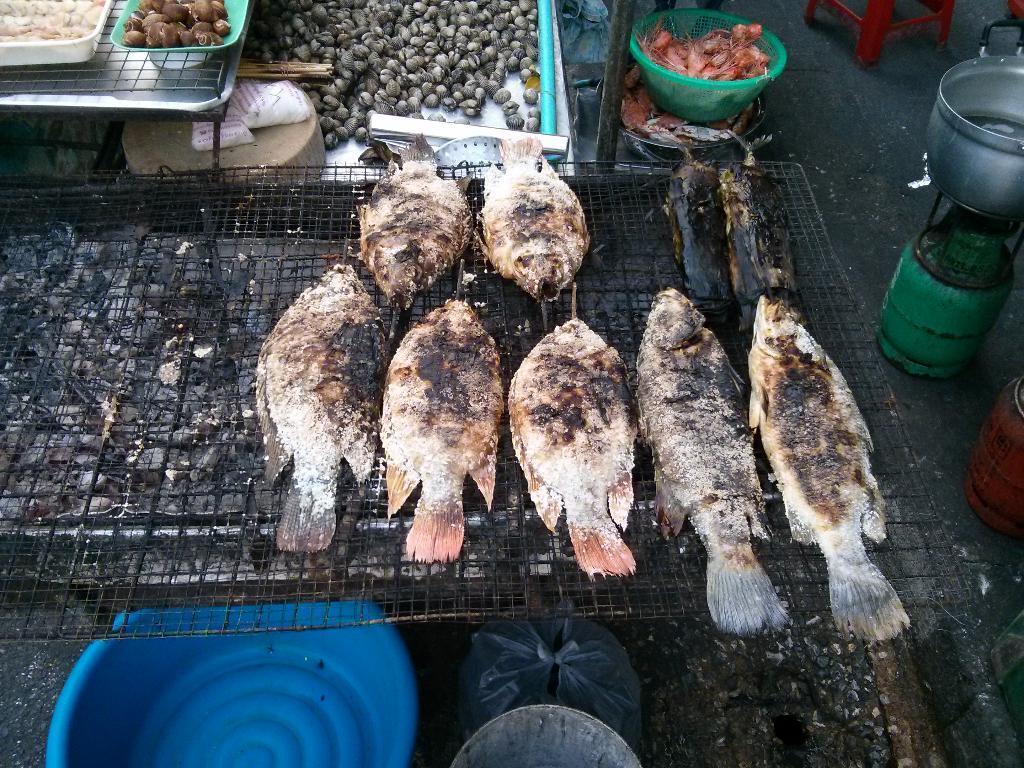Could you give a brief overview of what you see in this image? In this image we can see a fishes, here is the cylinder, and vessel on it, here is the tub on the ground, here is the food item in the basket. 